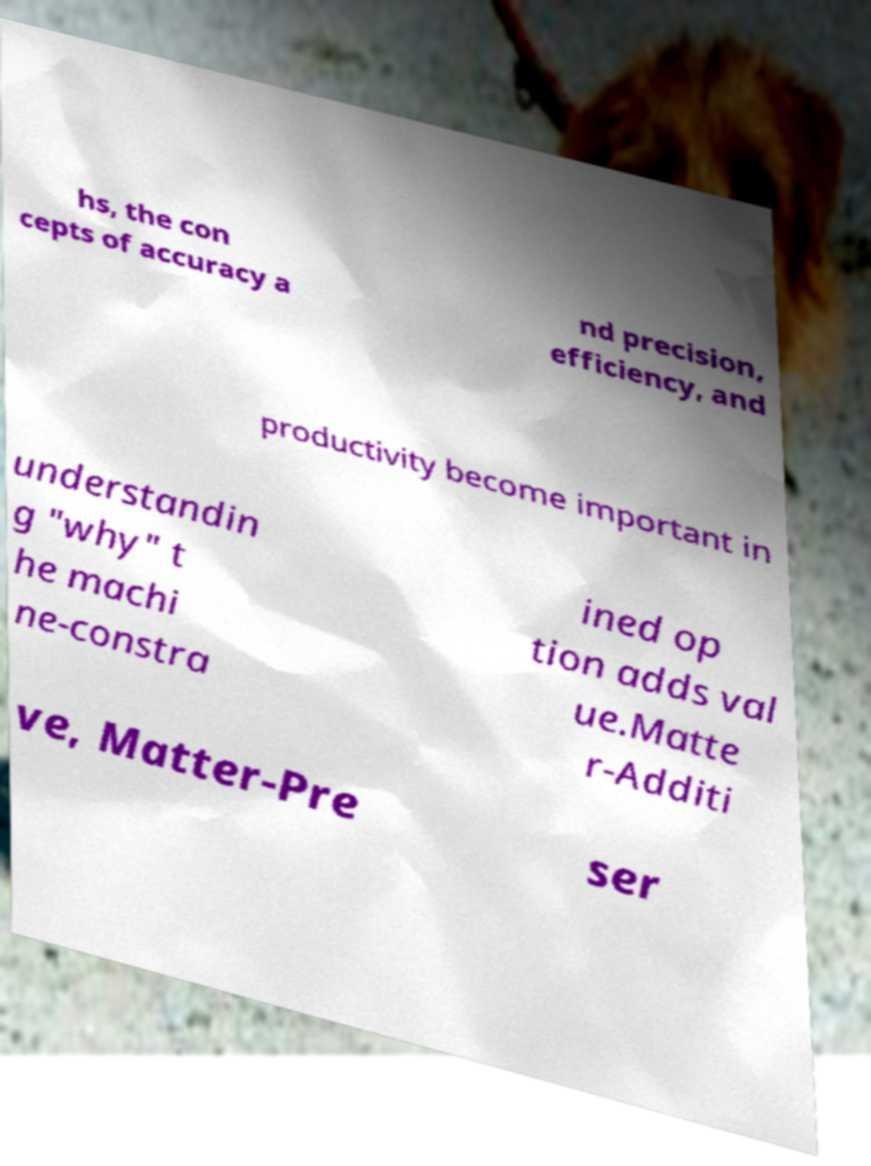Could you extract and type out the text from this image? hs, the con cepts of accuracy a nd precision, efficiency, and productivity become important in understandin g "why" t he machi ne-constra ined op tion adds val ue.Matte r-Additi ve, Matter-Pre ser 